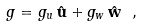Convert formula to latex. <formula><loc_0><loc_0><loc_500><loc_500>g = g _ { u } \, \hat { \mathbf u } + g _ { w } \, \hat { \mathbf w } \ ,</formula> 